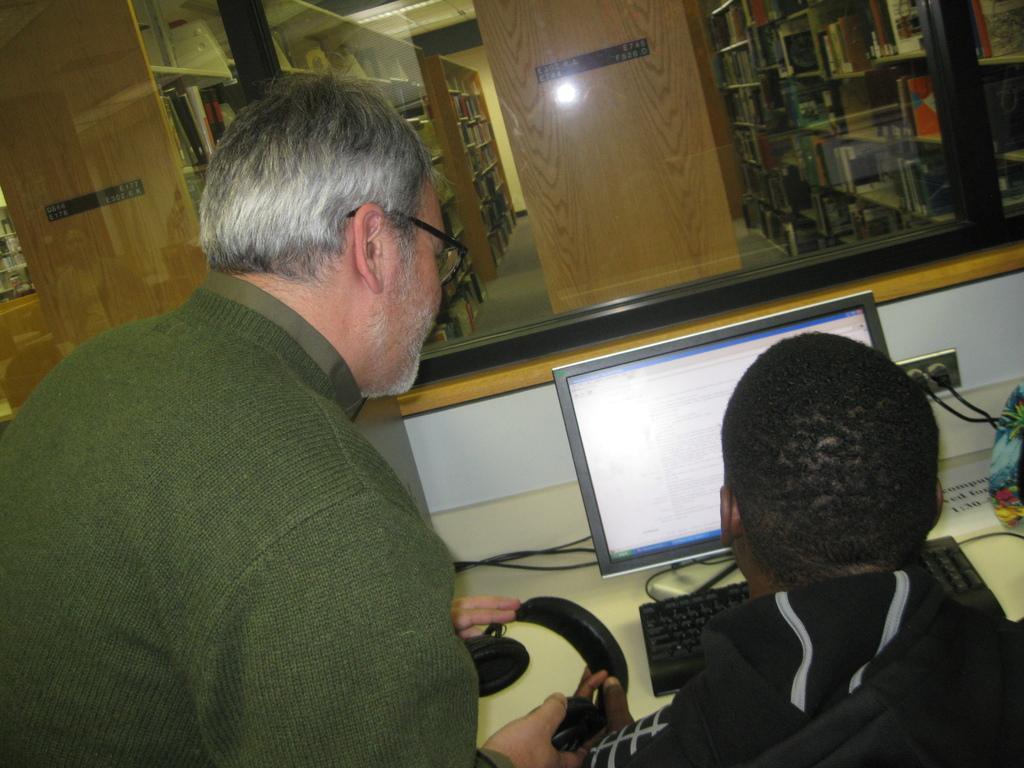How would you summarize this image in a sentence or two? In this image we can see a person standing and a person sitting at the desk before the desktop. In the background we can see books arranged in the cupboards, electric lights, cables, and a person holding headphones in the hands. 